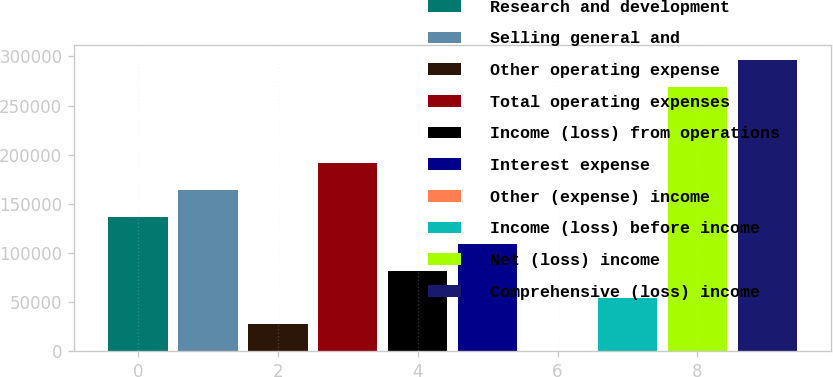Convert chart to OTSL. <chart><loc_0><loc_0><loc_500><loc_500><bar_chart><fcel>Research and development<fcel>Selling general and<fcel>Other operating expense<fcel>Total operating expenses<fcel>Income (loss) from operations<fcel>Interest expense<fcel>Other (expense) income<fcel>Income (loss) before income<fcel>Net (loss) income<fcel>Comprehensive (loss) income<nl><fcel>136917<fcel>164299<fcel>27389.8<fcel>191681<fcel>82153.4<fcel>109535<fcel>8<fcel>54771.6<fcel>268950<fcel>296332<nl></chart> 